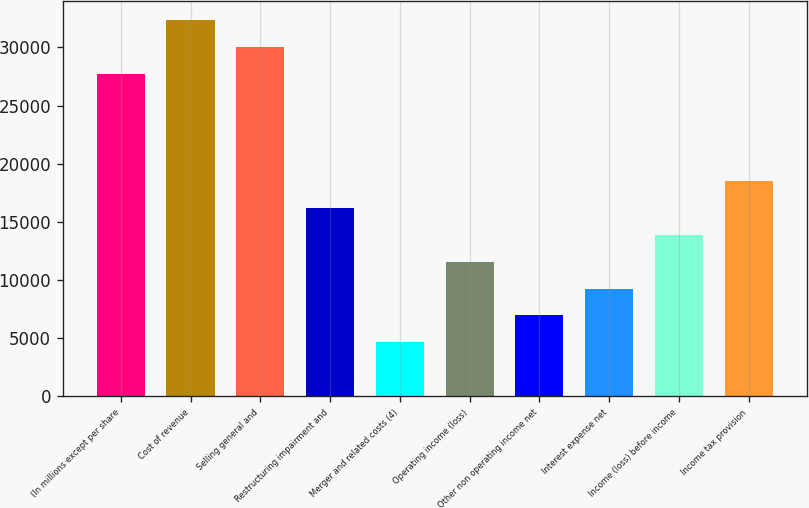Convert chart. <chart><loc_0><loc_0><loc_500><loc_500><bar_chart><fcel>(In millions except per share<fcel>Cost of revenue<fcel>Selling general and<fcel>Restructuring impairment and<fcel>Merger and related costs (4)<fcel>Operating income (loss)<fcel>Other non operating income net<fcel>Interest expense net<fcel>Income (loss) before income<fcel>Income tax provision<nl><fcel>27757<fcel>32381<fcel>30069<fcel>16197<fcel>4637<fcel>11573<fcel>6949<fcel>9261<fcel>13885<fcel>18509<nl></chart> 